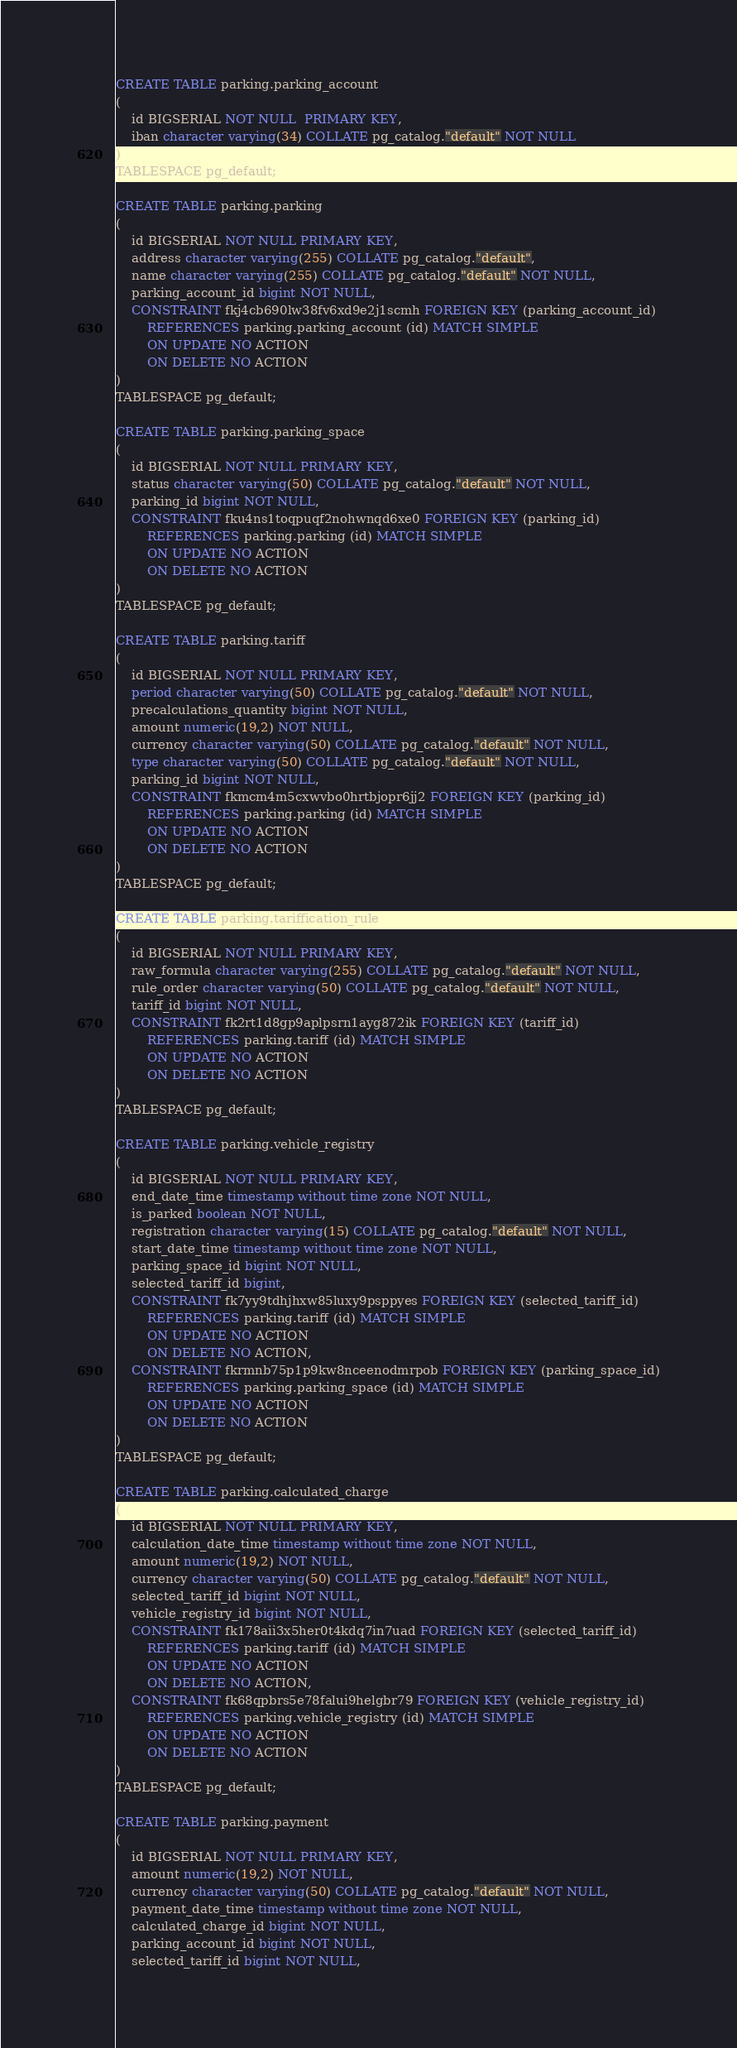<code> <loc_0><loc_0><loc_500><loc_500><_SQL_>CREATE TABLE parking.parking_account
(
    id BIGSERIAL NOT NULL  PRIMARY KEY,
    iban character varying(34) COLLATE pg_catalog."default" NOT NULL
)
TABLESPACE pg_default;

CREATE TABLE parking.parking
(
    id BIGSERIAL NOT NULL PRIMARY KEY,
    address character varying(255) COLLATE pg_catalog."default",
    name character varying(255) COLLATE pg_catalog."default" NOT NULL,
    parking_account_id bigint NOT NULL,
    CONSTRAINT fkj4cb690lw38fv6xd9e2j1scmh FOREIGN KEY (parking_account_id)
        REFERENCES parking.parking_account (id) MATCH SIMPLE
        ON UPDATE NO ACTION
        ON DELETE NO ACTION
)
TABLESPACE pg_default;

CREATE TABLE parking.parking_space
(
    id BIGSERIAL NOT NULL PRIMARY KEY,
    status character varying(50) COLLATE pg_catalog."default" NOT NULL,
    parking_id bigint NOT NULL,
    CONSTRAINT fku4ns1toqpuqf2nohwnqd6xe0 FOREIGN KEY (parking_id)
        REFERENCES parking.parking (id) MATCH SIMPLE
        ON UPDATE NO ACTION
        ON DELETE NO ACTION
)
TABLESPACE pg_default;

CREATE TABLE parking.tariff
(
    id BIGSERIAL NOT NULL PRIMARY KEY,
    period character varying(50) COLLATE pg_catalog."default" NOT NULL,
    precalculations_quantity bigint NOT NULL,
    amount numeric(19,2) NOT NULL,
    currency character varying(50) COLLATE pg_catalog."default" NOT NULL,
    type character varying(50) COLLATE pg_catalog."default" NOT NULL,
    parking_id bigint NOT NULL,
    CONSTRAINT fkmcm4m5cxwvbo0hrtbjopr6jj2 FOREIGN KEY (parking_id)
        REFERENCES parking.parking (id) MATCH SIMPLE
        ON UPDATE NO ACTION
        ON DELETE NO ACTION
)
TABLESPACE pg_default;

CREATE TABLE parking.tariffication_rule
(
    id BIGSERIAL NOT NULL PRIMARY KEY,
    raw_formula character varying(255) COLLATE pg_catalog."default" NOT NULL,
    rule_order character varying(50) COLLATE pg_catalog."default" NOT NULL,
    tariff_id bigint NOT NULL,
    CONSTRAINT fk2rt1d8gp9aplpsrn1ayg872ik FOREIGN KEY (tariff_id)
        REFERENCES parking.tariff (id) MATCH SIMPLE
        ON UPDATE NO ACTION
        ON DELETE NO ACTION
)
TABLESPACE pg_default;

CREATE TABLE parking.vehicle_registry
(
    id BIGSERIAL NOT NULL PRIMARY KEY,
    end_date_time timestamp without time zone NOT NULL,
    is_parked boolean NOT NULL,
    registration character varying(15) COLLATE pg_catalog."default" NOT NULL,
    start_date_time timestamp without time zone NOT NULL,
    parking_space_id bigint NOT NULL,
    selected_tariff_id bigint,
    CONSTRAINT fk7yy9tdhjhxw85luxy9psppyes FOREIGN KEY (selected_tariff_id)
        REFERENCES parking.tariff (id) MATCH SIMPLE
        ON UPDATE NO ACTION
        ON DELETE NO ACTION,
    CONSTRAINT fkrmnb75p1p9kw8nceenodmrpob FOREIGN KEY (parking_space_id)
        REFERENCES parking.parking_space (id) MATCH SIMPLE
        ON UPDATE NO ACTION
        ON DELETE NO ACTION
)
TABLESPACE pg_default;

CREATE TABLE parking.calculated_charge
(
    id BIGSERIAL NOT NULL PRIMARY KEY,
    calculation_date_time timestamp without time zone NOT NULL,
    amount numeric(19,2) NOT NULL,
    currency character varying(50) COLLATE pg_catalog."default" NOT NULL,
    selected_tariff_id bigint NOT NULL,
    vehicle_registry_id bigint NOT NULL,
    CONSTRAINT fk178aii3x5her0t4kdq7in7uad FOREIGN KEY (selected_tariff_id)
        REFERENCES parking.tariff (id) MATCH SIMPLE
        ON UPDATE NO ACTION
        ON DELETE NO ACTION,
    CONSTRAINT fk68qpbrs5e78falui9helgbr79 FOREIGN KEY (vehicle_registry_id)
        REFERENCES parking.vehicle_registry (id) MATCH SIMPLE
        ON UPDATE NO ACTION
        ON DELETE NO ACTION
)
TABLESPACE pg_default;

CREATE TABLE parking.payment
(
    id BIGSERIAL NOT NULL PRIMARY KEY,
    amount numeric(19,2) NOT NULL,
    currency character varying(50) COLLATE pg_catalog."default" NOT NULL,
    payment_date_time timestamp without time zone NOT NULL,
    calculated_charge_id bigint NOT NULL,
    parking_account_id bigint NOT NULL,
    selected_tariff_id bigint NOT NULL,</code> 